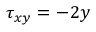<formula> <loc_0><loc_0><loc_500><loc_500>\tau _ { x y } = - 2 y</formula> 